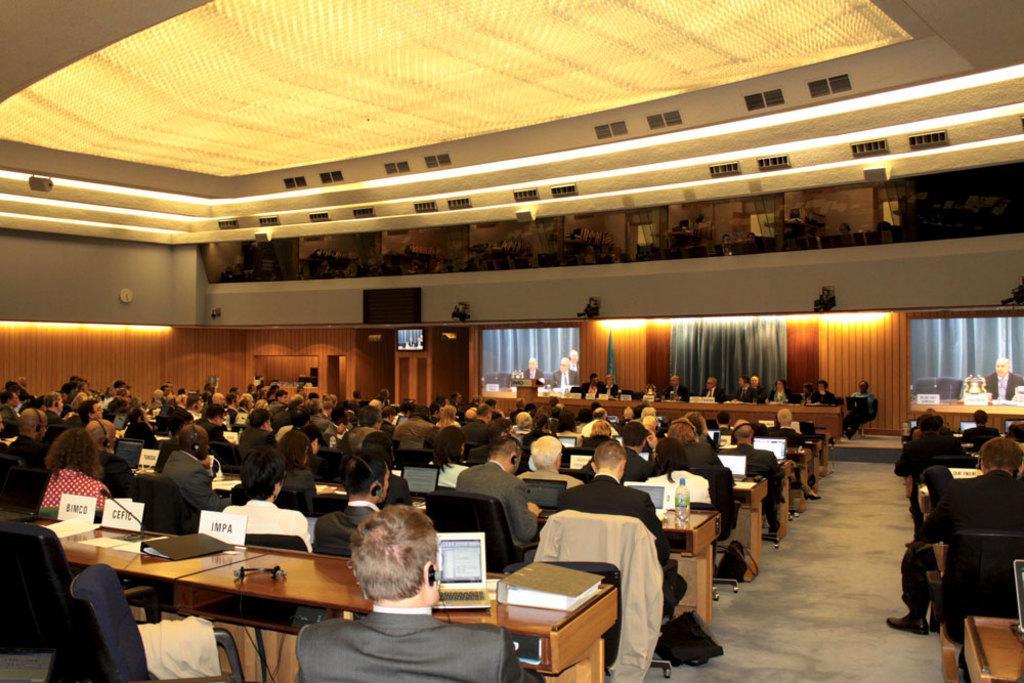How would you summarize this image in a sentence or two? This is a an Auditorium or Meeting hall, there are group of people attended to this meeting and there is a man standing over here giving a speech or explaining about something and the people over here are listening to him and there are lights at the middle of the image and the ceiling is of yellow color 